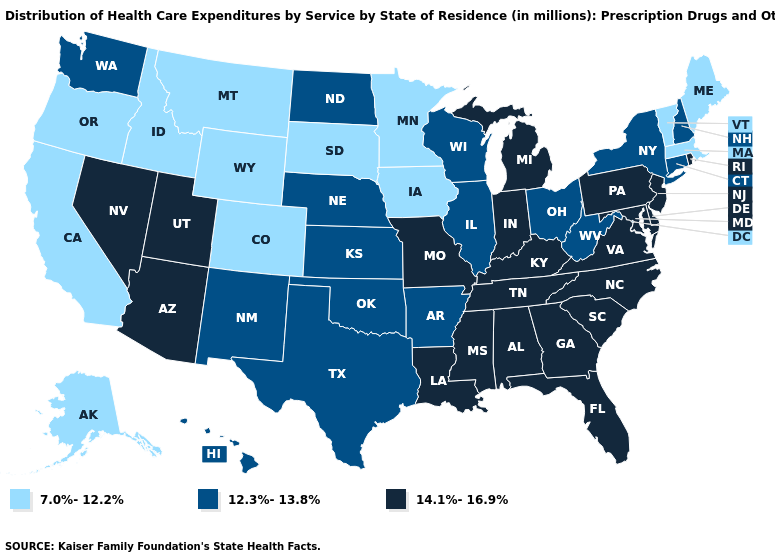Does the map have missing data?
Concise answer only. No. What is the value of Wisconsin?
Keep it brief. 12.3%-13.8%. What is the value of Georgia?
Write a very short answer. 14.1%-16.9%. Does Kentucky have the lowest value in the USA?
Concise answer only. No. Among the states that border New Mexico , which have the lowest value?
Give a very brief answer. Colorado. Name the states that have a value in the range 12.3%-13.8%?
Quick response, please. Arkansas, Connecticut, Hawaii, Illinois, Kansas, Nebraska, New Hampshire, New Mexico, New York, North Dakota, Ohio, Oklahoma, Texas, Washington, West Virginia, Wisconsin. What is the value of Washington?
Write a very short answer. 12.3%-13.8%. What is the highest value in states that border Virginia?
Answer briefly. 14.1%-16.9%. Does the map have missing data?
Give a very brief answer. No. What is the value of Vermont?
Write a very short answer. 7.0%-12.2%. Does Alaska have the highest value in the West?
Concise answer only. No. Which states have the lowest value in the USA?
Be succinct. Alaska, California, Colorado, Idaho, Iowa, Maine, Massachusetts, Minnesota, Montana, Oregon, South Dakota, Vermont, Wyoming. What is the value of Washington?
Be succinct. 12.3%-13.8%. What is the value of Iowa?
Answer briefly. 7.0%-12.2%. Does Ohio have the same value as Indiana?
Answer briefly. No. 